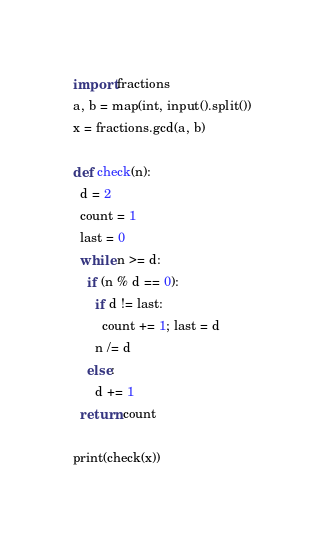<code> <loc_0><loc_0><loc_500><loc_500><_Python_>import fractions
a, b = map(int, input().split())
x = fractions.gcd(a, b)

def check(n):
  d = 2
  count = 1
  last = 0
  while n >= d:
    if (n % d == 0):
      if d != last:
        count += 1; last = d
      n /= d
    else:
      d += 1
  return count

print(check(x))
</code> 